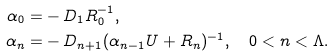<formula> <loc_0><loc_0><loc_500><loc_500>\alpha _ { 0 } = & - D _ { 1 } R _ { 0 } ^ { - 1 } , \\ \alpha _ { n } = & - D _ { n + 1 } ( \alpha _ { n - 1 } U + R _ { n } ) ^ { - 1 } , \quad 0 < n < \Lambda .</formula> 